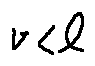Convert formula to latex. <formula><loc_0><loc_0><loc_500><loc_500>v < l</formula> 